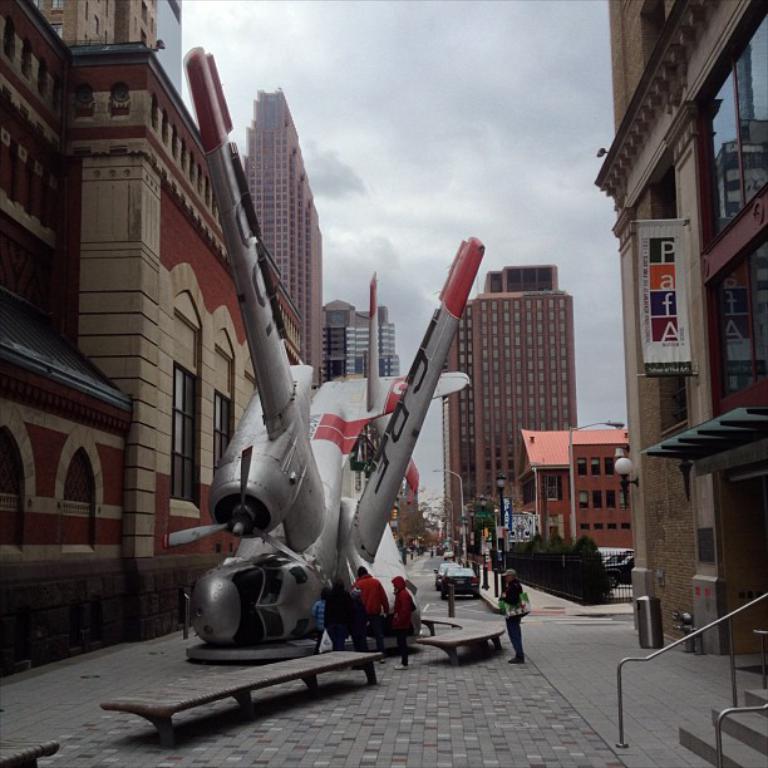In one or two sentences, can you explain what this image depicts? In foreground of the image we can see road, stairs and rods. In the middle of the image we can see some persons, one person is standing alone and carrying a bag, an aeroplane is crashed, some cars and building are there. On top of the image we can see the sky. 